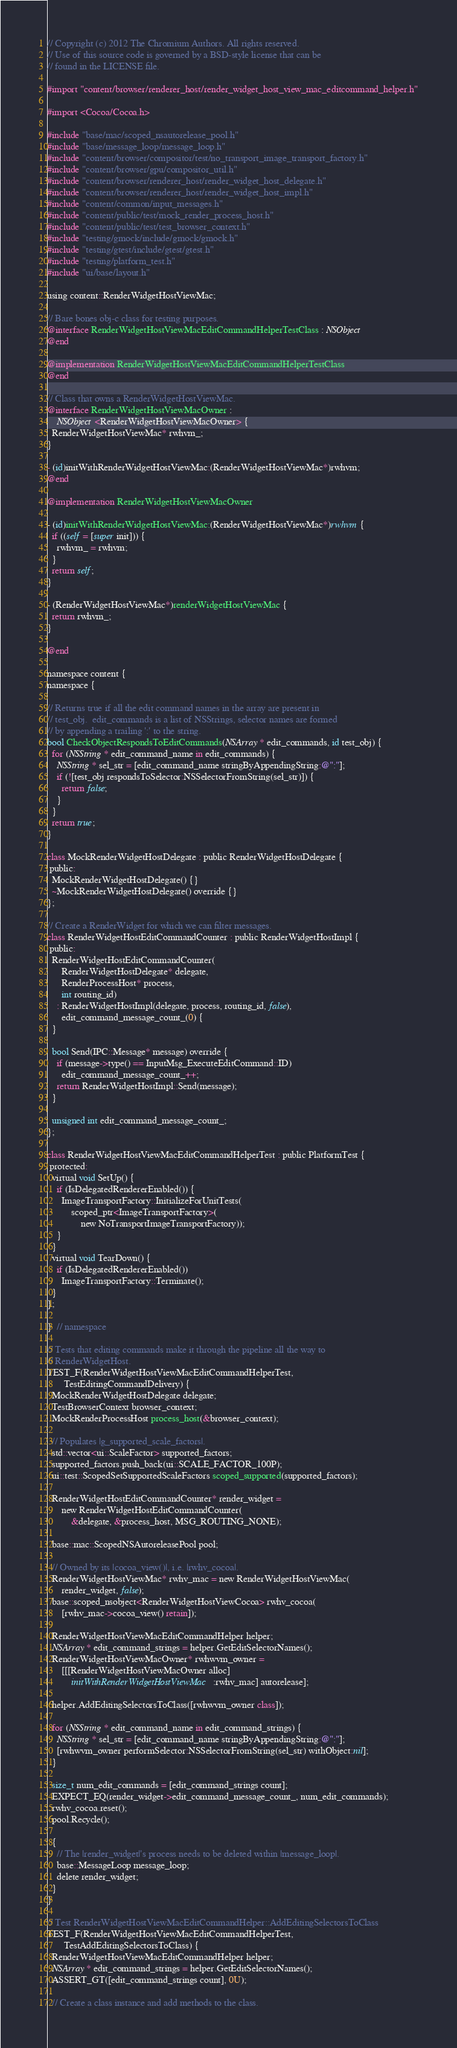<code> <loc_0><loc_0><loc_500><loc_500><_ObjectiveC_>// Copyright (c) 2012 The Chromium Authors. All rights reserved.
// Use of this source code is governed by a BSD-style license that can be
// found in the LICENSE file.

#import "content/browser/renderer_host/render_widget_host_view_mac_editcommand_helper.h"

#import <Cocoa/Cocoa.h>

#include "base/mac/scoped_nsautorelease_pool.h"
#include "base/message_loop/message_loop.h"
#include "content/browser/compositor/test/no_transport_image_transport_factory.h"
#include "content/browser/gpu/compositor_util.h"
#include "content/browser/renderer_host/render_widget_host_delegate.h"
#include "content/browser/renderer_host/render_widget_host_impl.h"
#include "content/common/input_messages.h"
#include "content/public/test/mock_render_process_host.h"
#include "content/public/test/test_browser_context.h"
#include "testing/gmock/include/gmock/gmock.h"
#include "testing/gtest/include/gtest/gtest.h"
#include "testing/platform_test.h"
#include "ui/base/layout.h"

using content::RenderWidgetHostViewMac;

// Bare bones obj-c class for testing purposes.
@interface RenderWidgetHostViewMacEditCommandHelperTestClass : NSObject
@end

@implementation RenderWidgetHostViewMacEditCommandHelperTestClass
@end

// Class that owns a RenderWidgetHostViewMac.
@interface RenderWidgetHostViewMacOwner :
    NSObject<RenderWidgetHostViewMacOwner> {
  RenderWidgetHostViewMac* rwhvm_;
}

- (id)initWithRenderWidgetHostViewMac:(RenderWidgetHostViewMac*)rwhvm;
@end

@implementation RenderWidgetHostViewMacOwner

- (id)initWithRenderWidgetHostViewMac:(RenderWidgetHostViewMac*)rwhvm {
  if ((self = [super init])) {
    rwhvm_ = rwhvm;
  }
  return self;
}

- (RenderWidgetHostViewMac*)renderWidgetHostViewMac {
  return rwhvm_;
}

@end

namespace content {
namespace {

// Returns true if all the edit command names in the array are present in
// test_obj.  edit_commands is a list of NSStrings, selector names are formed
// by appending a trailing ':' to the string.
bool CheckObjectRespondsToEditCommands(NSArray* edit_commands, id test_obj) {
  for (NSString* edit_command_name in edit_commands) {
    NSString* sel_str = [edit_command_name stringByAppendingString:@":"];
    if (![test_obj respondsToSelector:NSSelectorFromString(sel_str)]) {
      return false;
    }
  }
  return true;
}

class MockRenderWidgetHostDelegate : public RenderWidgetHostDelegate {
 public:
  MockRenderWidgetHostDelegate() {}
  ~MockRenderWidgetHostDelegate() override {}
};

// Create a RenderWidget for which we can filter messages.
class RenderWidgetHostEditCommandCounter : public RenderWidgetHostImpl {
 public:
  RenderWidgetHostEditCommandCounter(
      RenderWidgetHostDelegate* delegate,
      RenderProcessHost* process,
      int routing_id)
    : RenderWidgetHostImpl(delegate, process, routing_id, false),
      edit_command_message_count_(0) {
  }

  bool Send(IPC::Message* message) override {
    if (message->type() == InputMsg_ExecuteEditCommand::ID)
      edit_command_message_count_++;
    return RenderWidgetHostImpl::Send(message);
  }

  unsigned int edit_command_message_count_;
};

class RenderWidgetHostViewMacEditCommandHelperTest : public PlatformTest {
 protected:
  virtual void SetUp() {
    if (IsDelegatedRendererEnabled()) {
      ImageTransportFactory::InitializeForUnitTests(
          scoped_ptr<ImageTransportFactory>(
              new NoTransportImageTransportFactory));
    }
  }
  virtual void TearDown() {
    if (IsDelegatedRendererEnabled())
      ImageTransportFactory::Terminate();
  }
};

}  // namespace

// Tests that editing commands make it through the pipeline all the way to
// RenderWidgetHost.
TEST_F(RenderWidgetHostViewMacEditCommandHelperTest,
       TestEditingCommandDelivery) {
  MockRenderWidgetHostDelegate delegate;
  TestBrowserContext browser_context;
  MockRenderProcessHost process_host(&browser_context);

  // Populates |g_supported_scale_factors|.
  std::vector<ui::ScaleFactor> supported_factors;
  supported_factors.push_back(ui::SCALE_FACTOR_100P);
  ui::test::ScopedSetSupportedScaleFactors scoped_supported(supported_factors);

  RenderWidgetHostEditCommandCounter* render_widget =
      new RenderWidgetHostEditCommandCounter(
          &delegate, &process_host, MSG_ROUTING_NONE);

  base::mac::ScopedNSAutoreleasePool pool;

  // Owned by its |cocoa_view()|, i.e. |rwhv_cocoa|.
  RenderWidgetHostViewMac* rwhv_mac = new RenderWidgetHostViewMac(
      render_widget, false);
  base::scoped_nsobject<RenderWidgetHostViewCocoa> rwhv_cocoa(
      [rwhv_mac->cocoa_view() retain]);

  RenderWidgetHostViewMacEditCommandHelper helper;
  NSArray* edit_command_strings = helper.GetEditSelectorNames();
  RenderWidgetHostViewMacOwner* rwhwvm_owner =
      [[[RenderWidgetHostViewMacOwner alloc]
          initWithRenderWidgetHostViewMac:rwhv_mac] autorelease];

  helper.AddEditingSelectorsToClass([rwhwvm_owner class]);

  for (NSString* edit_command_name in edit_command_strings) {
    NSString* sel_str = [edit_command_name stringByAppendingString:@":"];
    [rwhwvm_owner performSelector:NSSelectorFromString(sel_str) withObject:nil];
  }

  size_t num_edit_commands = [edit_command_strings count];
  EXPECT_EQ(render_widget->edit_command_message_count_, num_edit_commands);
  rwhv_cocoa.reset();
  pool.Recycle();

  {
    // The |render_widget|'s process needs to be deleted within |message_loop|.
    base::MessageLoop message_loop;
    delete render_widget;
  }
}

// Test RenderWidgetHostViewMacEditCommandHelper::AddEditingSelectorsToClass
TEST_F(RenderWidgetHostViewMacEditCommandHelperTest,
       TestAddEditingSelectorsToClass) {
  RenderWidgetHostViewMacEditCommandHelper helper;
  NSArray* edit_command_strings = helper.GetEditSelectorNames();
  ASSERT_GT([edit_command_strings count], 0U);

  // Create a class instance and add methods to the class.</code> 